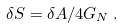<formula> <loc_0><loc_0><loc_500><loc_500>\delta S = \delta A / 4 G _ { N } \, .</formula> 